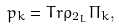Convert formula to latex. <formula><loc_0><loc_0><loc_500><loc_500>p _ { k } = T r \rho _ { 2 _ { L } } \Pi _ { k } ,</formula> 